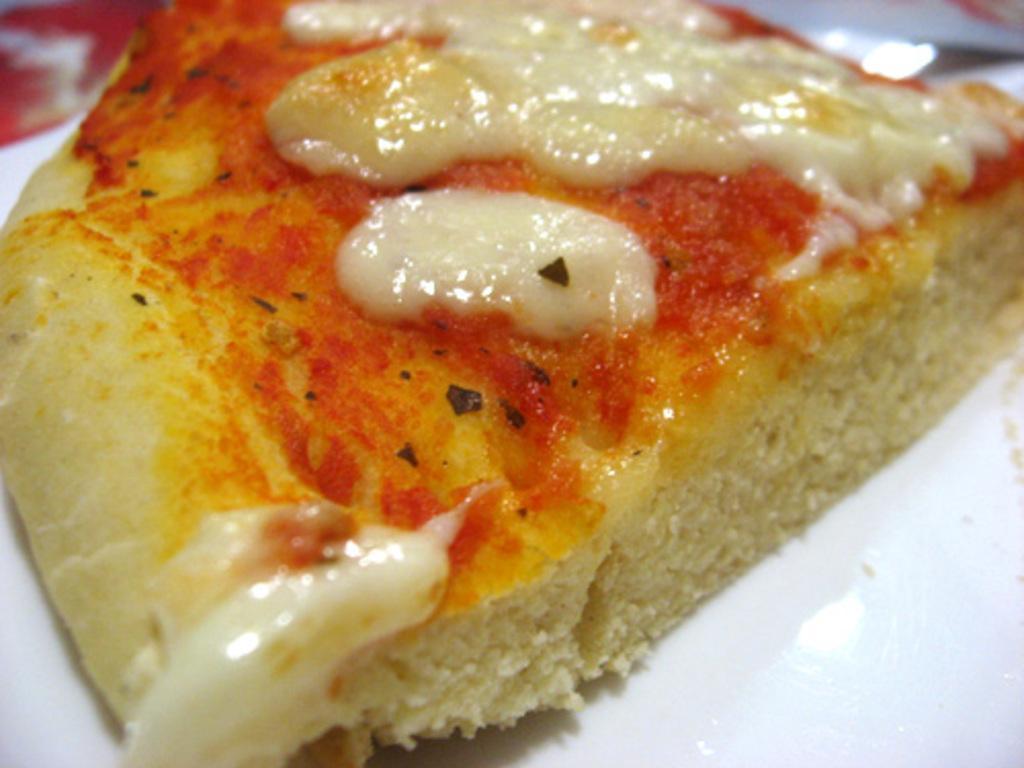In one or two sentences, can you explain what this image depicts? In this image I can see food item on a white color plate. 